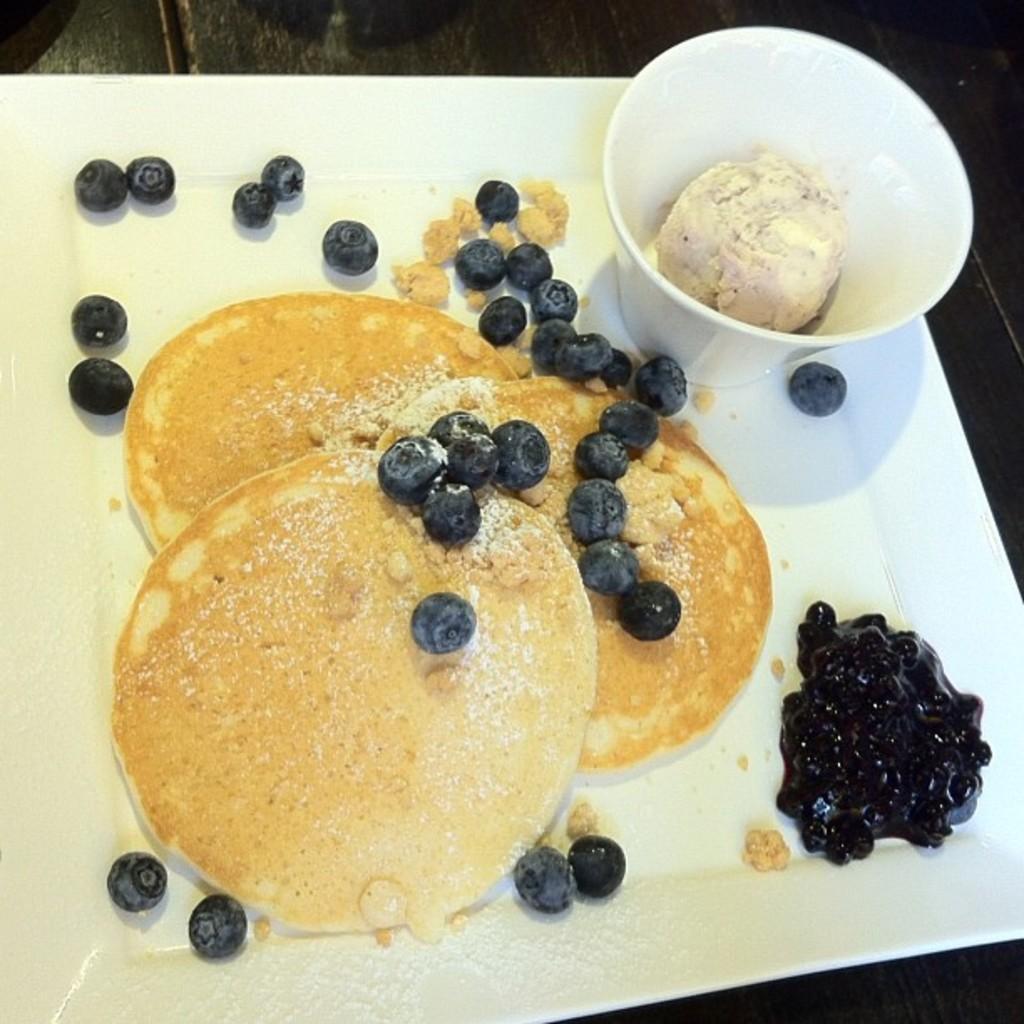Can you describe this image briefly? In this picture we can see some food items and a cup on the white plate. In the cup there is food. 